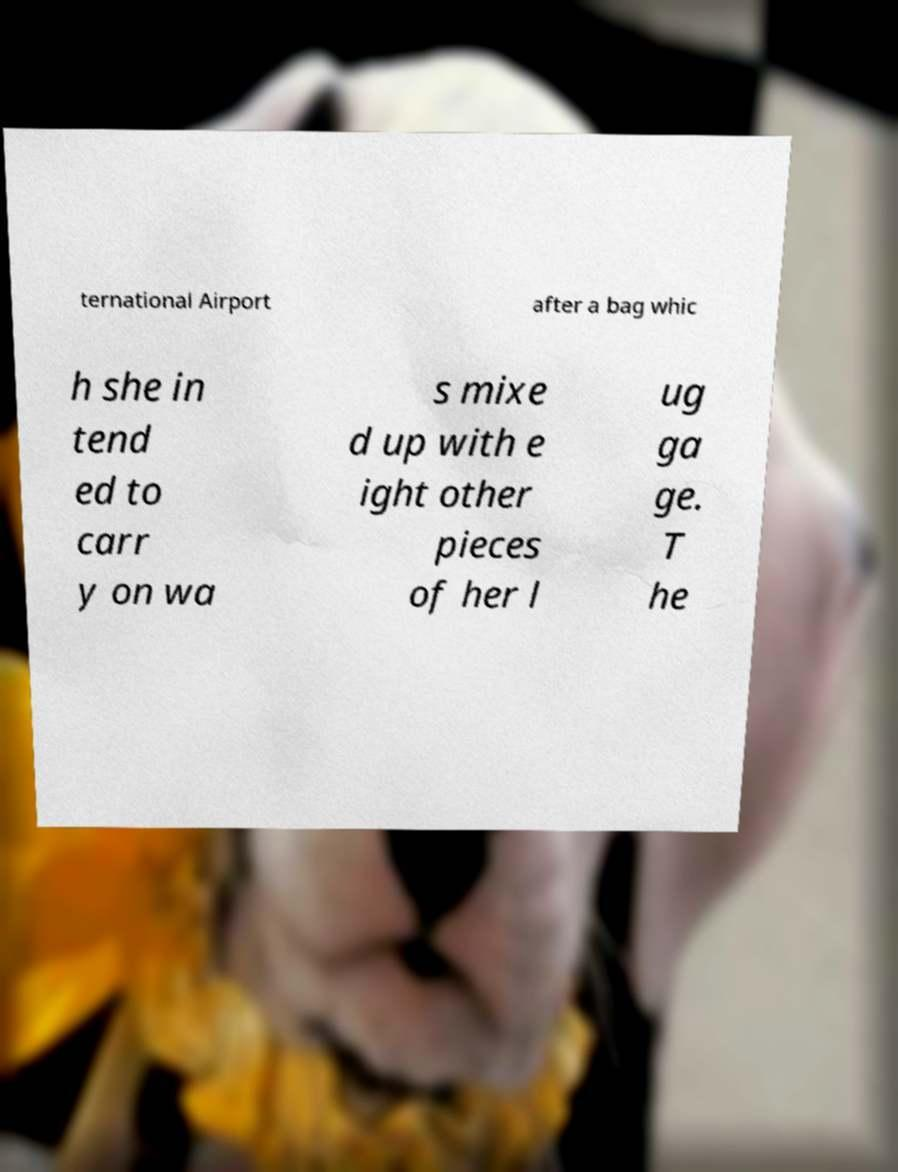Could you extract and type out the text from this image? ternational Airport after a bag whic h she in tend ed to carr y on wa s mixe d up with e ight other pieces of her l ug ga ge. T he 